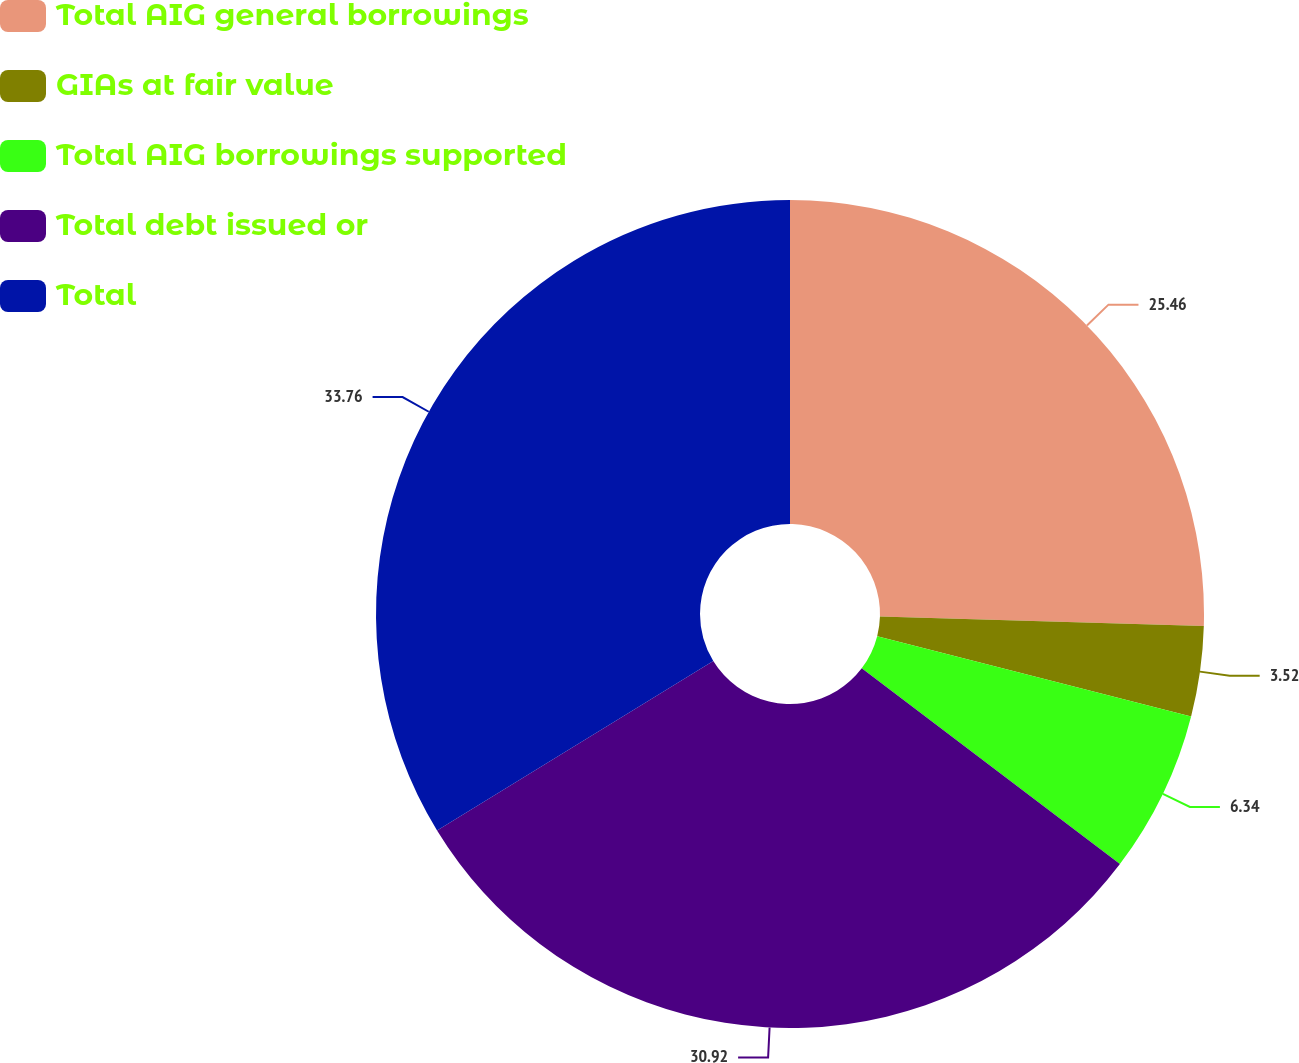Convert chart. <chart><loc_0><loc_0><loc_500><loc_500><pie_chart><fcel>Total AIG general borrowings<fcel>GIAs at fair value<fcel>Total AIG borrowings supported<fcel>Total debt issued or<fcel>Total<nl><fcel>25.46%<fcel>3.52%<fcel>6.34%<fcel>30.92%<fcel>33.75%<nl></chart> 